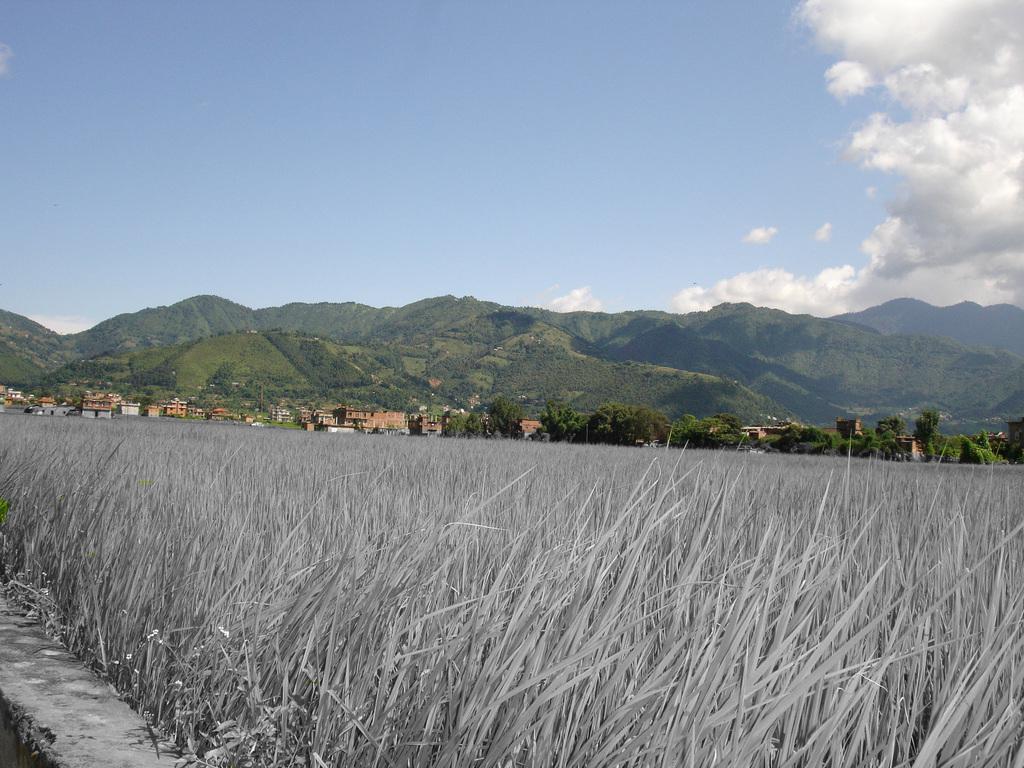Describe this image in one or two sentences. In the center of the image we can see a buildings, trees and mountains are present. At the bottom of the image grass is there. At the top of the image clouds are present in the sky. 